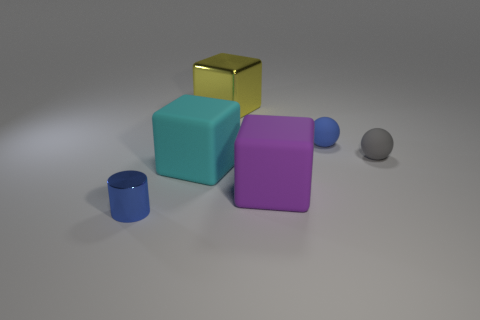There is a cyan object that is the same size as the yellow shiny cube; what is its material?
Offer a very short reply. Rubber. How many other things are there of the same material as the tiny blue ball?
Make the answer very short. 3. There is a blue thing that is in front of the blue rubber thing; is its shape the same as the small blue object behind the tiny blue cylinder?
Your response must be concise. No. What number of other objects are the same color as the small metallic thing?
Provide a short and direct response. 1. Do the blue thing to the left of the purple rubber cube and the blue object behind the large cyan rubber block have the same material?
Make the answer very short. No. Are there an equal number of yellow blocks behind the yellow cube and rubber things that are in front of the blue metallic object?
Provide a succinct answer. Yes. There is a blue object behind the tiny gray matte sphere; what is its material?
Your answer should be compact. Rubber. Is there any other thing that is the same size as the gray sphere?
Your answer should be very brief. Yes. Are there fewer large purple shiny cylinders than yellow metallic cubes?
Keep it short and to the point. Yes. There is a small thing that is both in front of the blue matte thing and behind the tiny metallic cylinder; what shape is it?
Keep it short and to the point. Sphere. 